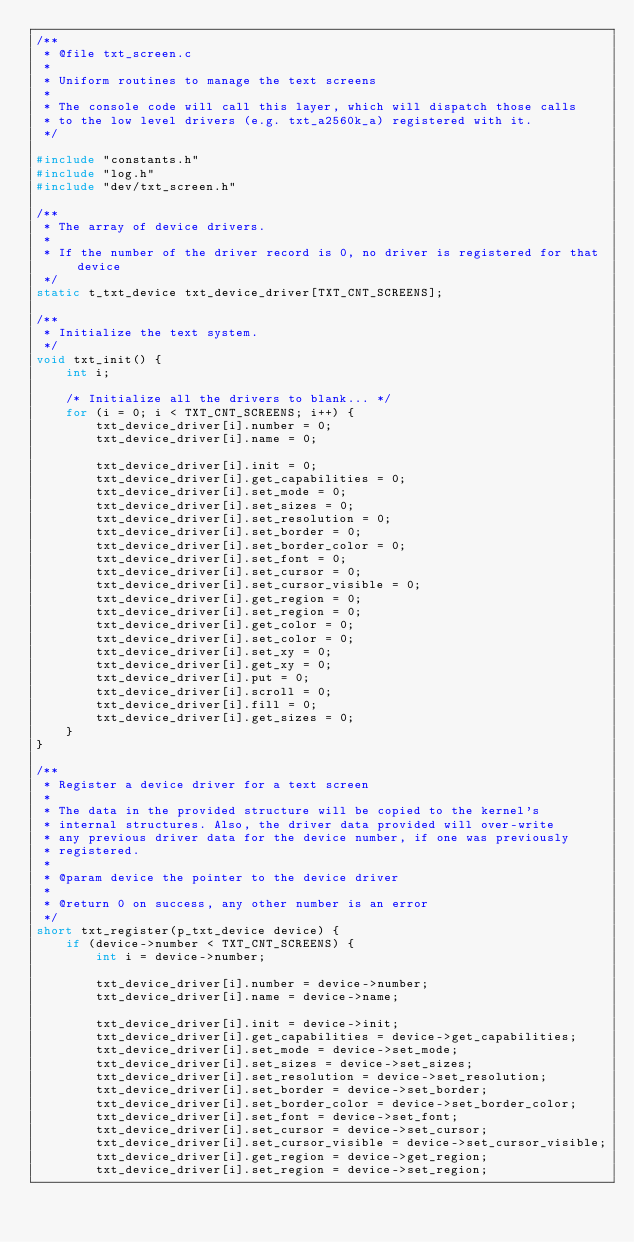Convert code to text. <code><loc_0><loc_0><loc_500><loc_500><_C_>/**
 * @file txt_screen.c
 *
 * Uniform routines to manage the text screens
 *
 * The console code will call this layer, which will dispatch those calls
 * to the low level drivers (e.g. txt_a2560k_a) registered with it.
 */

#include "constants.h"
#include "log.h"
#include "dev/txt_screen.h"

/**
 * The array of device drivers.
 *
 * If the number of the driver record is 0, no driver is registered for that device
 */
static t_txt_device txt_device_driver[TXT_CNT_SCREENS];

/**
 * Initialize the text system.
 */
void txt_init() {
    int i;

    /* Initialize all the drivers to blank... */
    for (i = 0; i < TXT_CNT_SCREENS; i++) {
        txt_device_driver[i].number = 0;
        txt_device_driver[i].name = 0;

        txt_device_driver[i].init = 0;
        txt_device_driver[i].get_capabilities = 0;
        txt_device_driver[i].set_mode = 0;
        txt_device_driver[i].set_sizes = 0;
        txt_device_driver[i].set_resolution = 0;
        txt_device_driver[i].set_border = 0;
        txt_device_driver[i].set_border_color = 0;
        txt_device_driver[i].set_font = 0;
        txt_device_driver[i].set_cursor = 0;
        txt_device_driver[i].set_cursor_visible = 0;
        txt_device_driver[i].get_region = 0;
        txt_device_driver[i].set_region = 0;
        txt_device_driver[i].get_color = 0;
        txt_device_driver[i].set_color = 0;
        txt_device_driver[i].set_xy = 0;
        txt_device_driver[i].get_xy = 0;
        txt_device_driver[i].put = 0;
        txt_device_driver[i].scroll = 0;
        txt_device_driver[i].fill = 0;
        txt_device_driver[i].get_sizes = 0;
    }
}

/**
 * Register a device driver for a text screen
 *
 * The data in the provided structure will be copied to the kernel's
 * internal structures. Also, the driver data provided will over-write
 * any previous driver data for the device number, if one was previously
 * registered.
 *
 * @param device the pointer to the device driver
 *
 * @return 0 on success, any other number is an error
 */
short txt_register(p_txt_device device) {
    if (device->number < TXT_CNT_SCREENS) {
        int i = device->number;

        txt_device_driver[i].number = device->number;
        txt_device_driver[i].name = device->name;

        txt_device_driver[i].init = device->init;
        txt_device_driver[i].get_capabilities = device->get_capabilities;
        txt_device_driver[i].set_mode = device->set_mode;
        txt_device_driver[i].set_sizes = device->set_sizes;
        txt_device_driver[i].set_resolution = device->set_resolution;
        txt_device_driver[i].set_border = device->set_border;
        txt_device_driver[i].set_border_color = device->set_border_color;
        txt_device_driver[i].set_font = device->set_font;
        txt_device_driver[i].set_cursor = device->set_cursor;
        txt_device_driver[i].set_cursor_visible = device->set_cursor_visible;
        txt_device_driver[i].get_region = device->get_region;
        txt_device_driver[i].set_region = device->set_region;</code> 